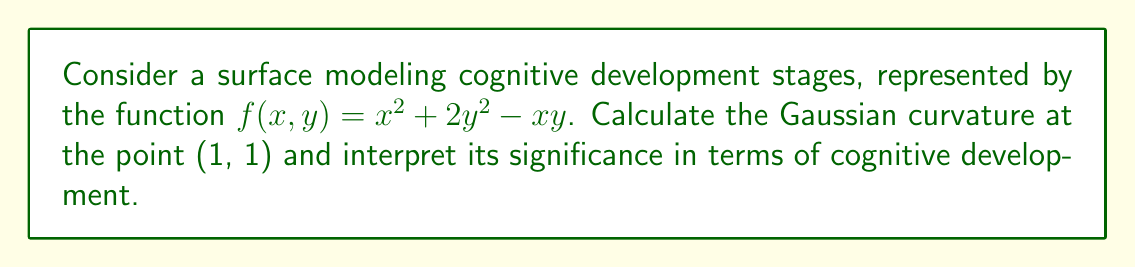Give your solution to this math problem. To calculate the Gaussian curvature, we need to follow these steps:

1) First, we need to calculate the partial derivatives:
   $f_x = 2x - y$
   $f_y = 4y - x$
   $f_{xx} = 2$
   $f_{yy} = 4$
   $f_{xy} = f_{yx} = -1$

2) Next, we calculate the coefficients of the first fundamental form:
   $E = 1 + f_x^2 = 1 + (2x - y)^2$
   $F = f_x f_y = (2x - y)(4y - x)$
   $G = 1 + f_y^2 = 1 + (4y - x)^2$

3) Now, we calculate the coefficients of the second fundamental form:
   $L = \frac{f_{xx}}{\sqrt{1 + f_x^2 + f_y^2}} = \frac{2}{\sqrt{1 + (2x - y)^2 + (4y - x)^2}}$
   $M = \frac{f_{xy}}{\sqrt{1 + f_x^2 + f_y^2}} = \frac{-1}{\sqrt{1 + (2x - y)^2 + (4y - x)^2}}$
   $N = \frac{f_{yy}}{\sqrt{1 + f_x^2 + f_y^2}} = \frac{4}{\sqrt{1 + (2x - y)^2 + (4y - x)^2}}$

4) The Gaussian curvature is given by:
   $K = \frac{LN - M^2}{EG - F^2}$

5) Substituting the point (1, 1):
   $E = 1 + (2(1) - 1)^2 = 2$
   $F = (2(1) - 1)(4(1) - 1) = 3$
   $G = 1 + (4(1) - 1)^2 = 10$
   $L = \frac{2}{\sqrt{1 + 1^2 + 3^2}} = \frac{2}{\sqrt{11}}$
   $M = \frac{-1}{\sqrt{11}}$
   $N = \frac{4}{\sqrt{11}}$

6) Calculating K:
   $K = \frac{(\frac{2}{\sqrt{11}})(\frac{4}{\sqrt{11}}) - (\frac{-1}{\sqrt{11}})^2}{(2)(10) - 3^2}$
   $= \frac{\frac{8}{11} + \frac{1}{11}}{20 - 9} = \frac{\frac{9}{11}}{11} = \frac{9}{121} \approx 0.0744$

7) Interpretation: The positive Gaussian curvature indicates that the surface is locally elliptic at (1, 1). In terms of cognitive development, this suggests a stable and well-defined stage of development at this point, with gradual changes in cognitive abilities in all directions around this stage.
Answer: $K = \frac{9}{121} \approx 0.0744$ 